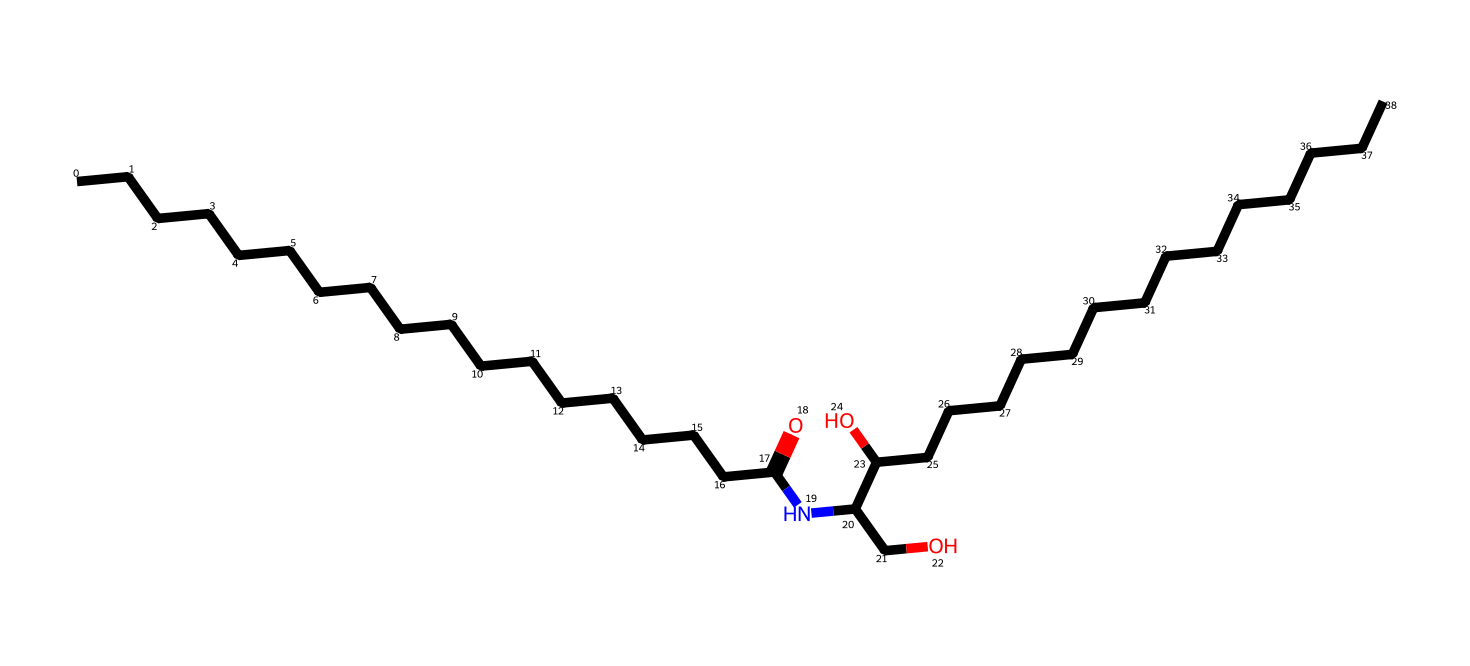What is the total number of carbon atoms in this ceramide? By analyzing the SMILES representation, we count the number of 'C' symbols. The structure indicates there are a total of 30 carbon atoms present.
Answer: 30 How many hydroxyl (OH) groups are in this molecule? In the provided SMILES, we notice two occurrences of 'O' that are part of -OH groups (attached to carbon atoms). Therefore, this molecule contains two hydroxyl groups.
Answer: 2 What functional group is indicated by the "NC" segment in the structure? The "NC" segment indicates the presence of an amine functional group (-NH) due to the nitrogen connected to a carbon, which is characteristic of ceramides.
Answer: amine What type of lipid is this molecule classified as? This molecule is classified as a ceramide, which is a type of sphingolipid that plays a key role in the structure of cell membranes.
Answer: ceramide How many double bonds are present in this molecular structure? The SMILES representation shows no double bond symbols (like '='), which indicates that there are zero double bonds in this molecule.
Answer: 0 What is the molecular weight of this ceramide? To answer this, we would calculate the molecular weight by summing the atomic weights of all the constituent atoms based on the count from the SMILES notation; the approximate molecular weight is 540 grams per mole.
Answer: 540 grams per mole 